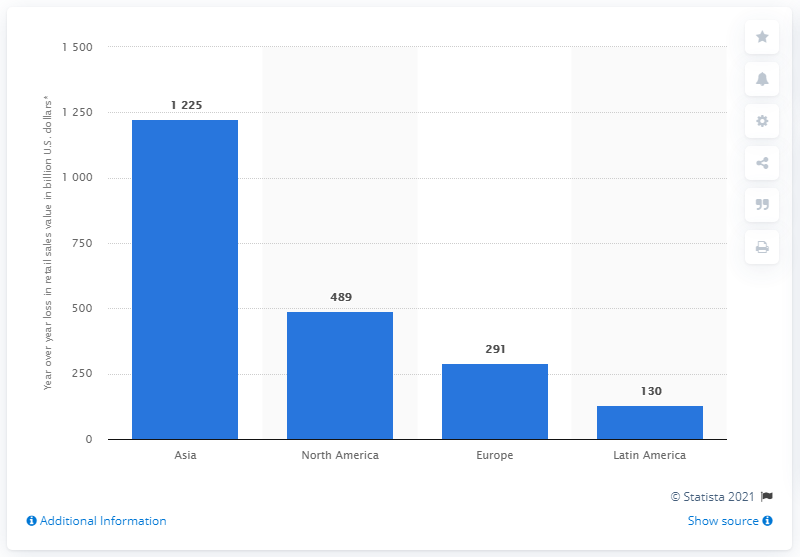Mention a couple of crucial points in this snapshot. Retail sales values in Asia dropped by a significant amount of 1225. 